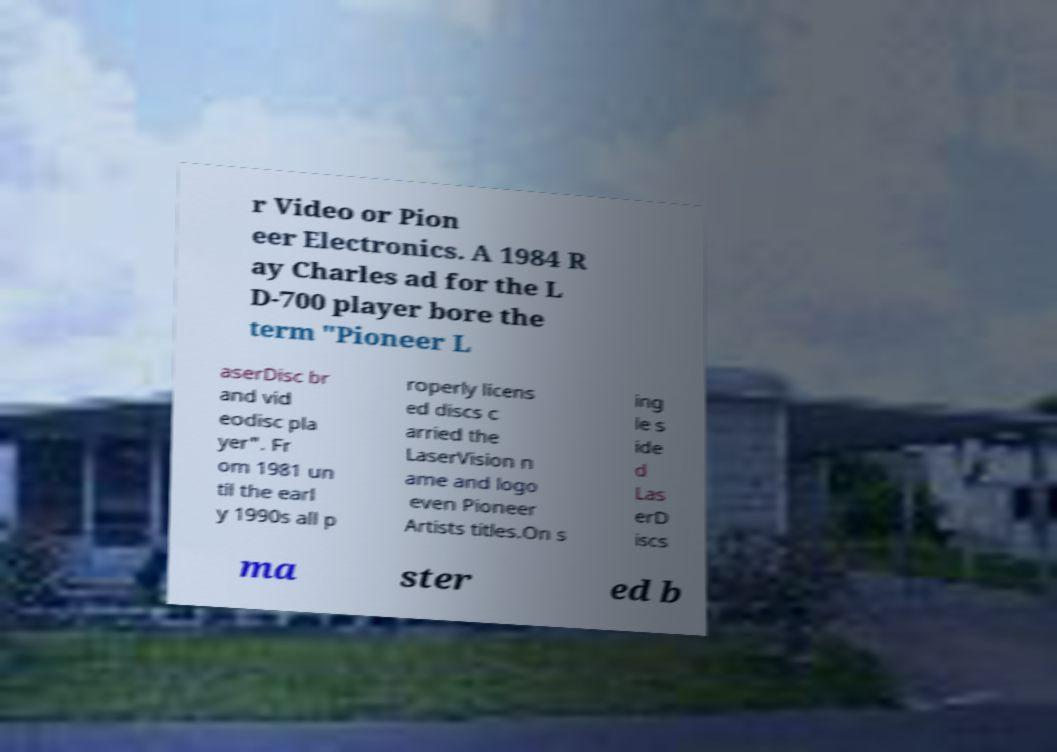Can you accurately transcribe the text from the provided image for me? r Video or Pion eer Electronics. A 1984 R ay Charles ad for the L D-700 player bore the term "Pioneer L aserDisc br and vid eodisc pla yer". Fr om 1981 un til the earl y 1990s all p roperly licens ed discs c arried the LaserVision n ame and logo even Pioneer Artists titles.On s ing le s ide d Las erD iscs ma ster ed b 